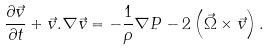<formula> <loc_0><loc_0><loc_500><loc_500>\frac { \partial \vec { v } } { \partial t } + \vec { v } . \nabla \vec { v } = - \frac { 1 } { \rho } \nabla P - 2 \left ( \vec { \Omega } \times \vec { v } \right ) .</formula> 